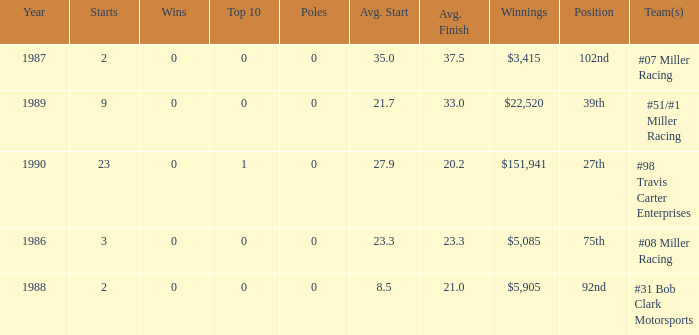What is the most recent year where the average start is 8.5? 1988.0. 